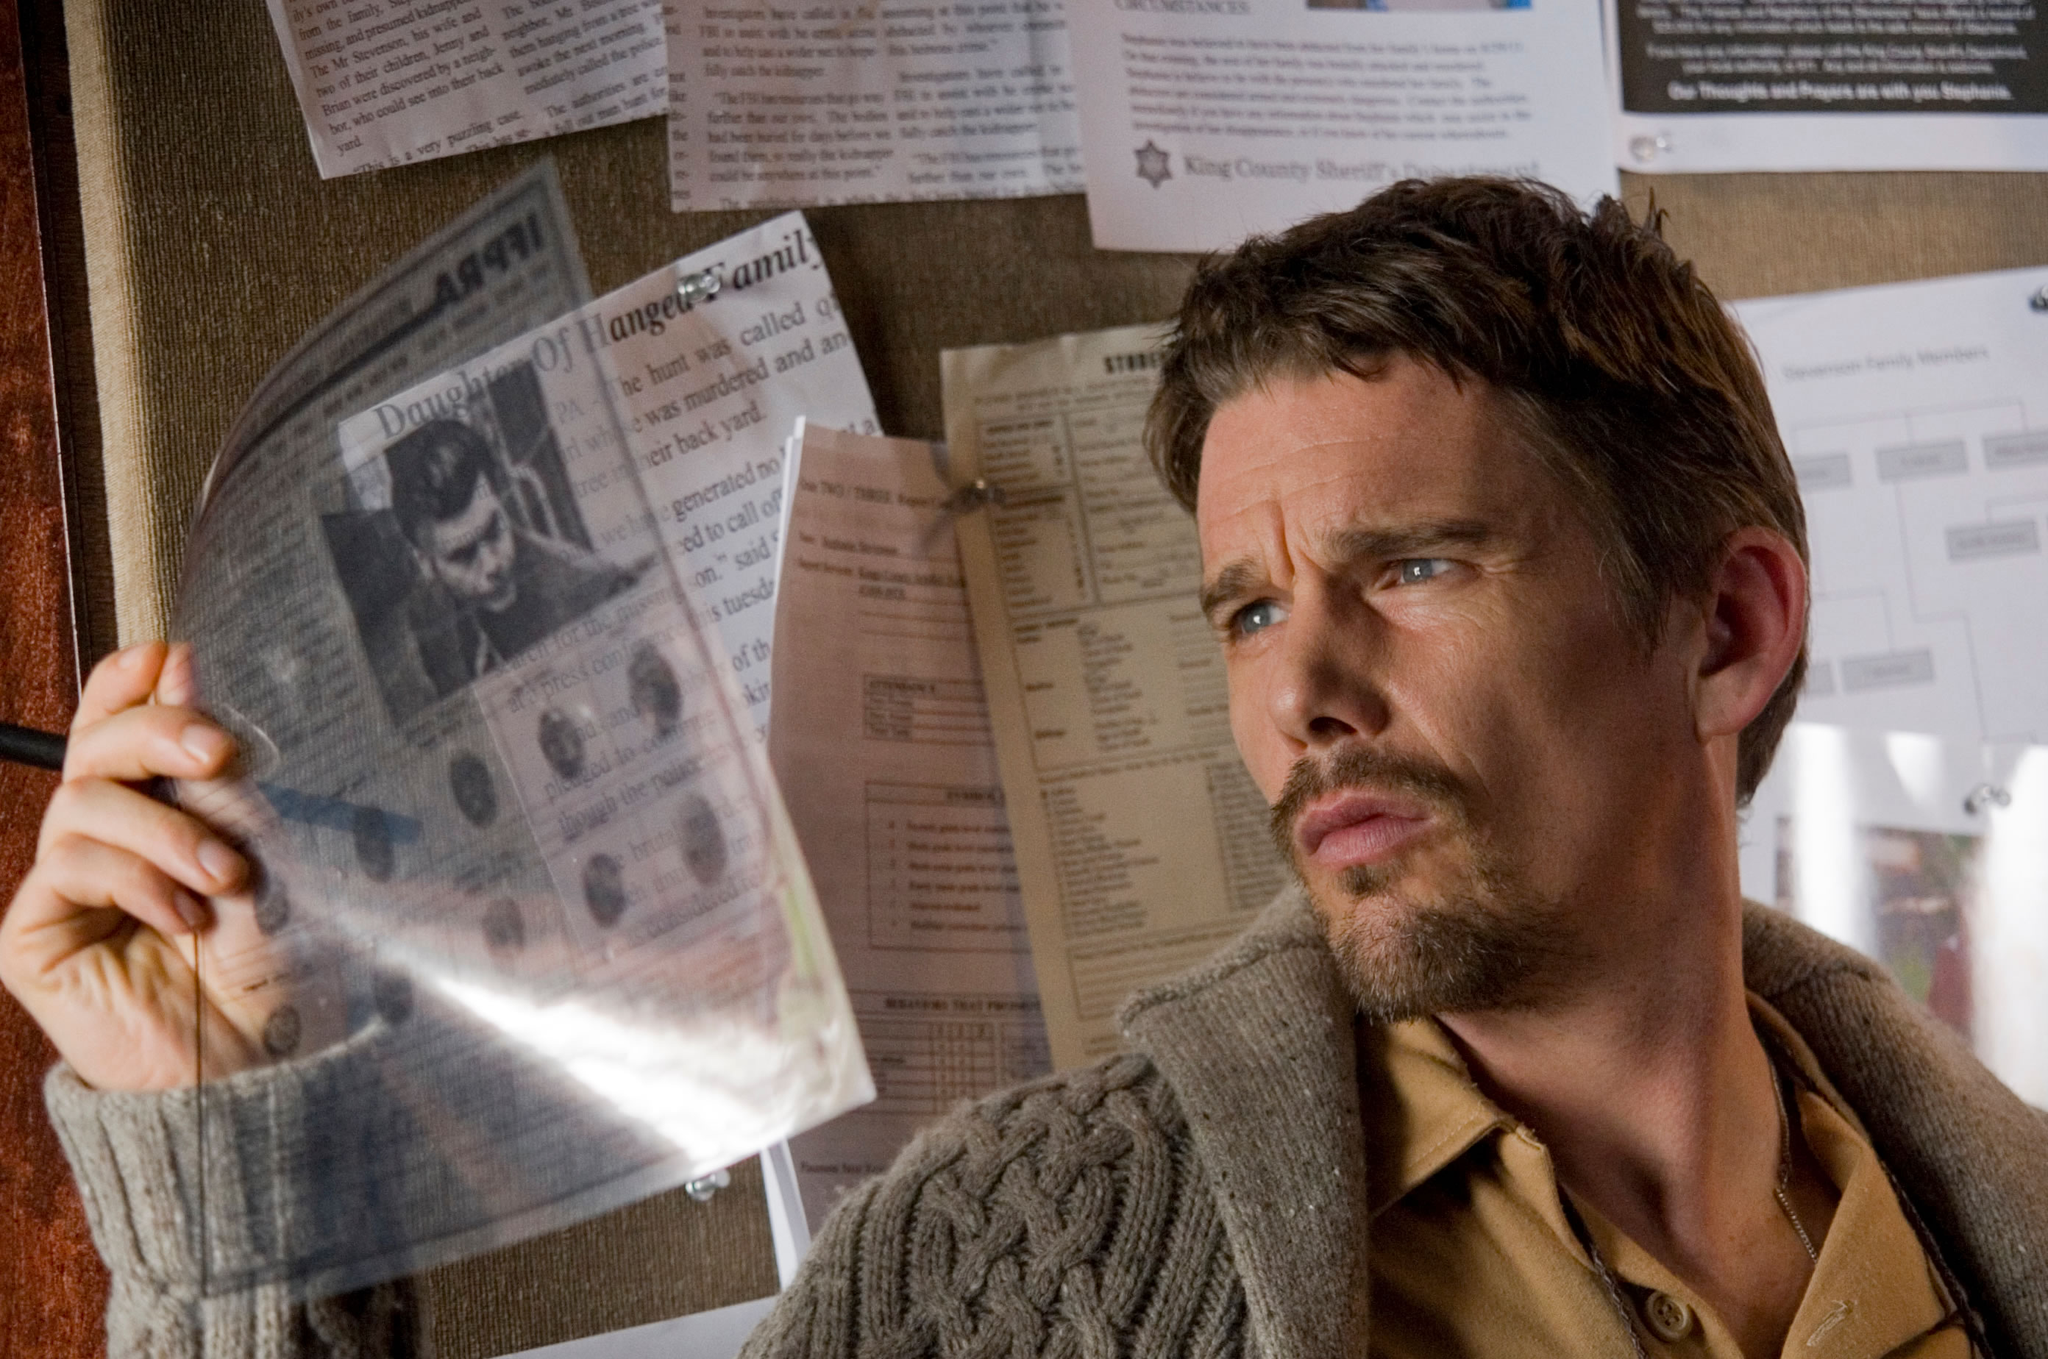What's happening in the scene? The image captures a scene of intense investigation or discovery. A man, dressed in a beige jacket and gray sweater, closely examines a newspaper clipping he is holding up. His surroundings, a bulletin board covered with various papers and documents, suggest he is deep in research, possibly trying to solve a mystery or piece together a complex issue. His serious expression and focused gaze indicate his deep engagement and concern with the matter at hand. 